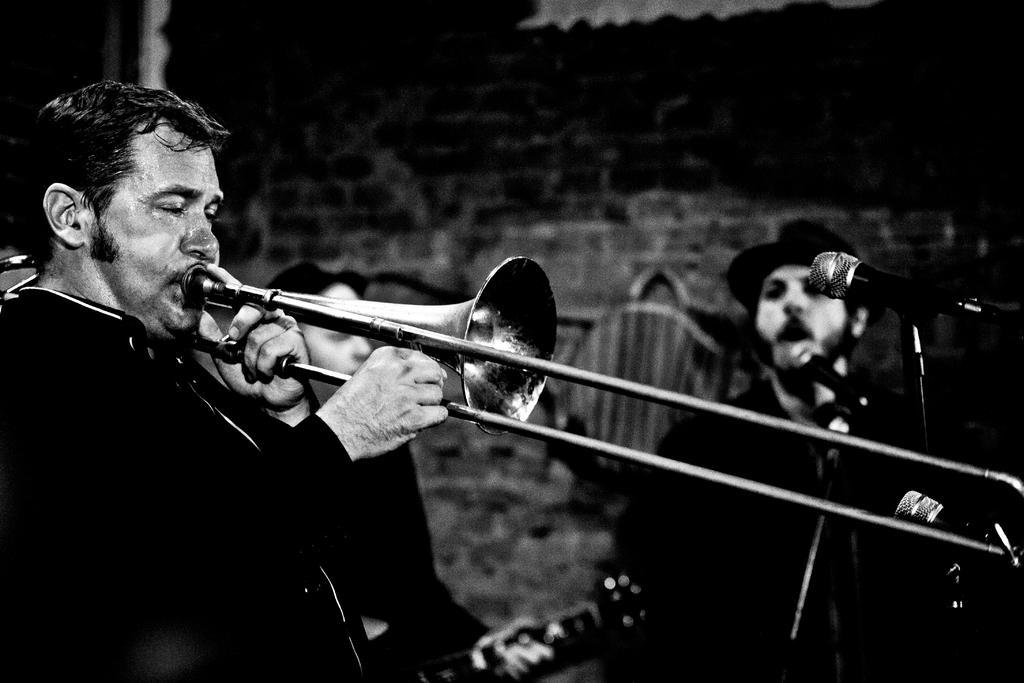Please provide a concise description of this image. It is a black and white picture. In this picture I can see people. Among them two people are playing musical instruments. On the right side of the image I can see a person and mics. In the background of the image it is blurry. 